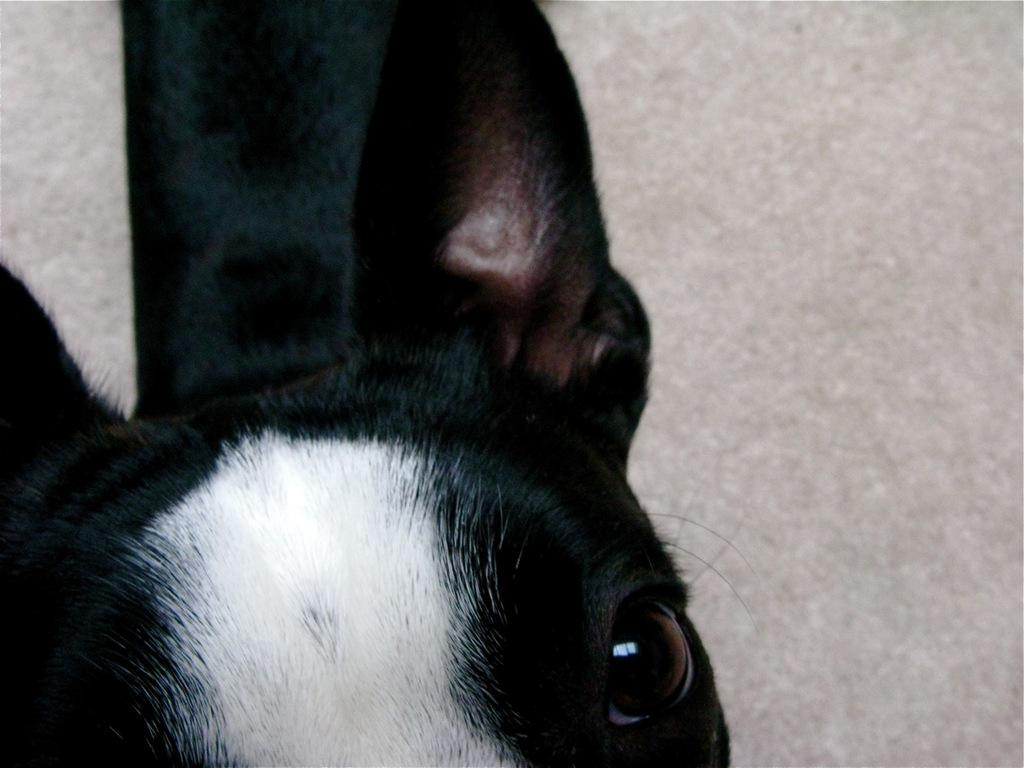What is the main subject of the image? There is an animal in the center of the image. Can you describe the appearance of the animal? The animal is black in color. What can be seen in the background of the image? There is a floor visible in the background of the image. What type of secretary is standing next to the animal in the image? There is no secretary present in the image; it only features an animal. What type of fireman is visible in the image? There is no fireman present in the image; it only features an animal. What type of donkey is visible in the image? The animal in the image is not a donkey; it is black in color, but the specific type of animal is not mentioned in the facts. 